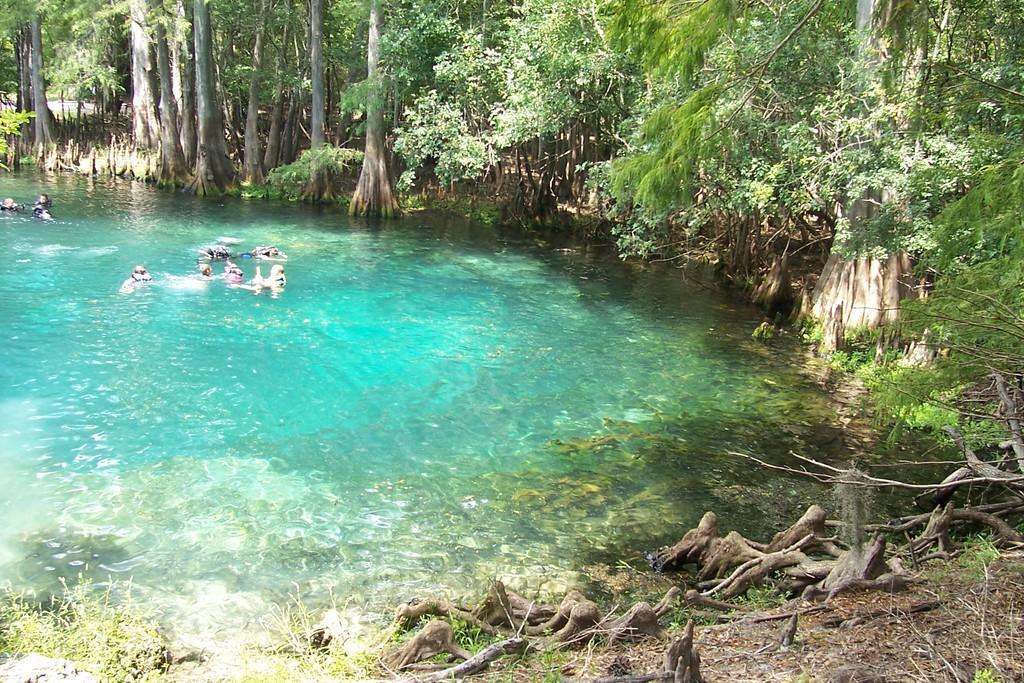What is the main subject in the center of the image? There is water in the center of the image. What are the people in the image doing? People are swimming in the water. What can be seen in the background of the image? There are trees in the background of the image. What is visible at the bottom of the image? Tree trunks and plants are visible at the bottom of the image. Can you see any errors in the image? There is no indication of any errors in the image. Is there a hill visible in the image? There is no hill present in the image; it features water, people swimming, trees, and plants. 